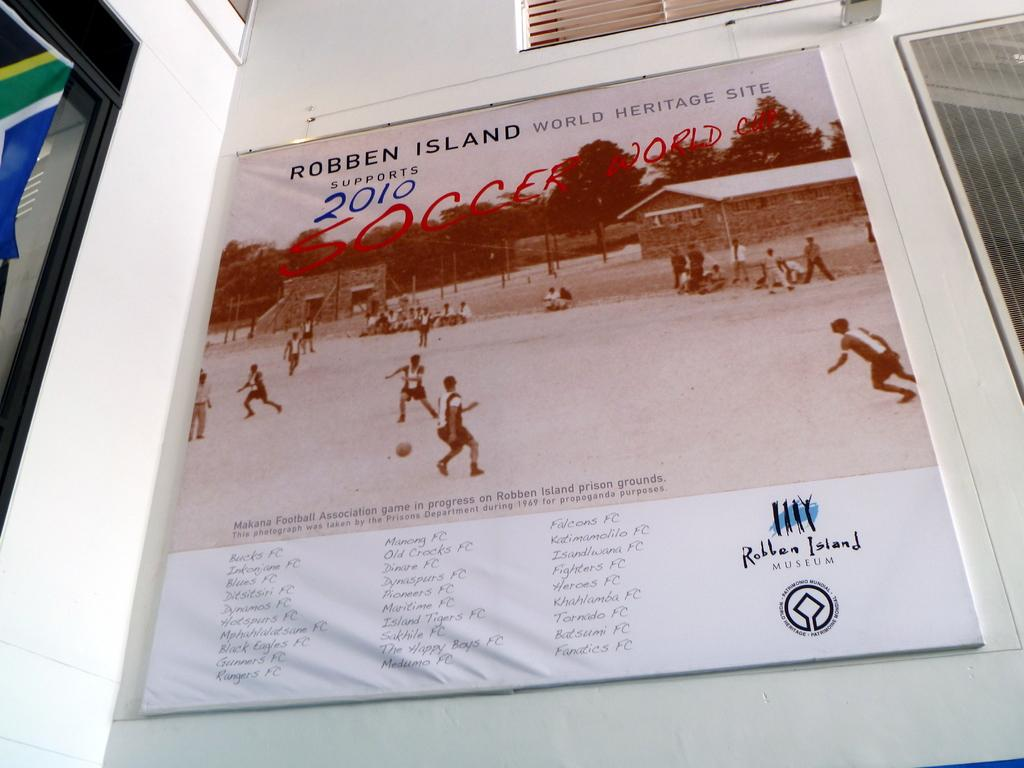<image>
Present a compact description of the photo's key features. A poster hanging on a wall depicts that the Robben Island World Heritage site supoorts the 2010 Soccer World Cup. 